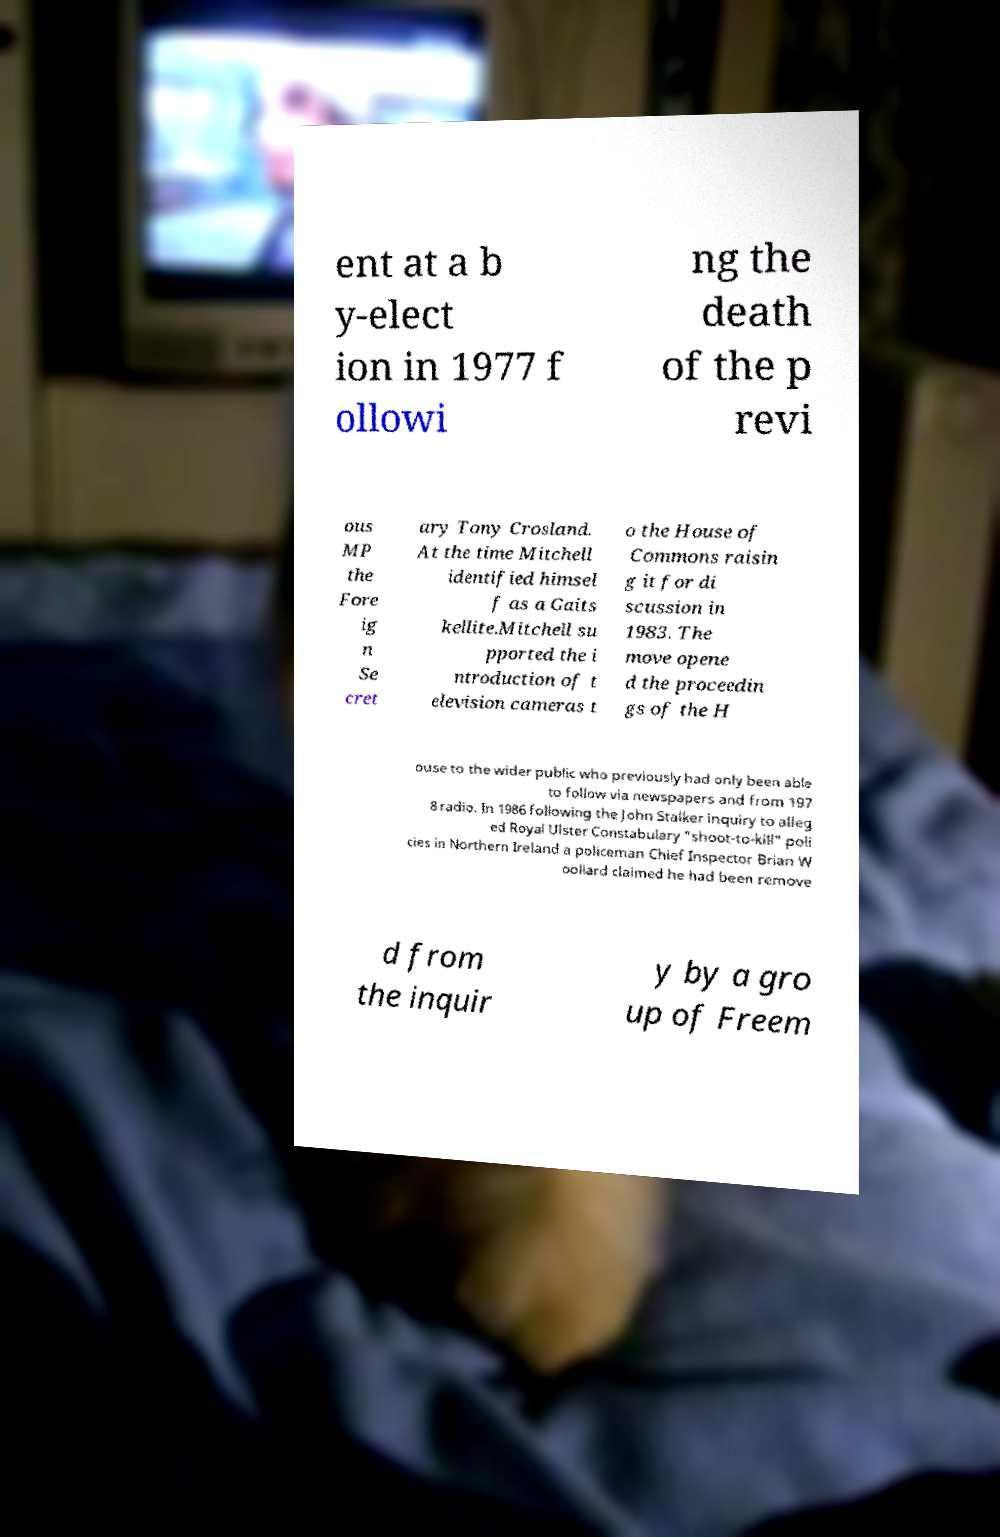For documentation purposes, I need the text within this image transcribed. Could you provide that? ent at a b y-elect ion in 1977 f ollowi ng the death of the p revi ous MP the Fore ig n Se cret ary Tony Crosland. At the time Mitchell identified himsel f as a Gaits kellite.Mitchell su pported the i ntroduction of t elevision cameras t o the House of Commons raisin g it for di scussion in 1983. The move opene d the proceedin gs of the H ouse to the wider public who previously had only been able to follow via newspapers and from 197 8 radio. In 1986 following the John Stalker inquiry to alleg ed Royal Ulster Constabulary "shoot-to-kill" poli cies in Northern Ireland a policeman Chief Inspector Brian W oollard claimed he had been remove d from the inquir y by a gro up of Freem 